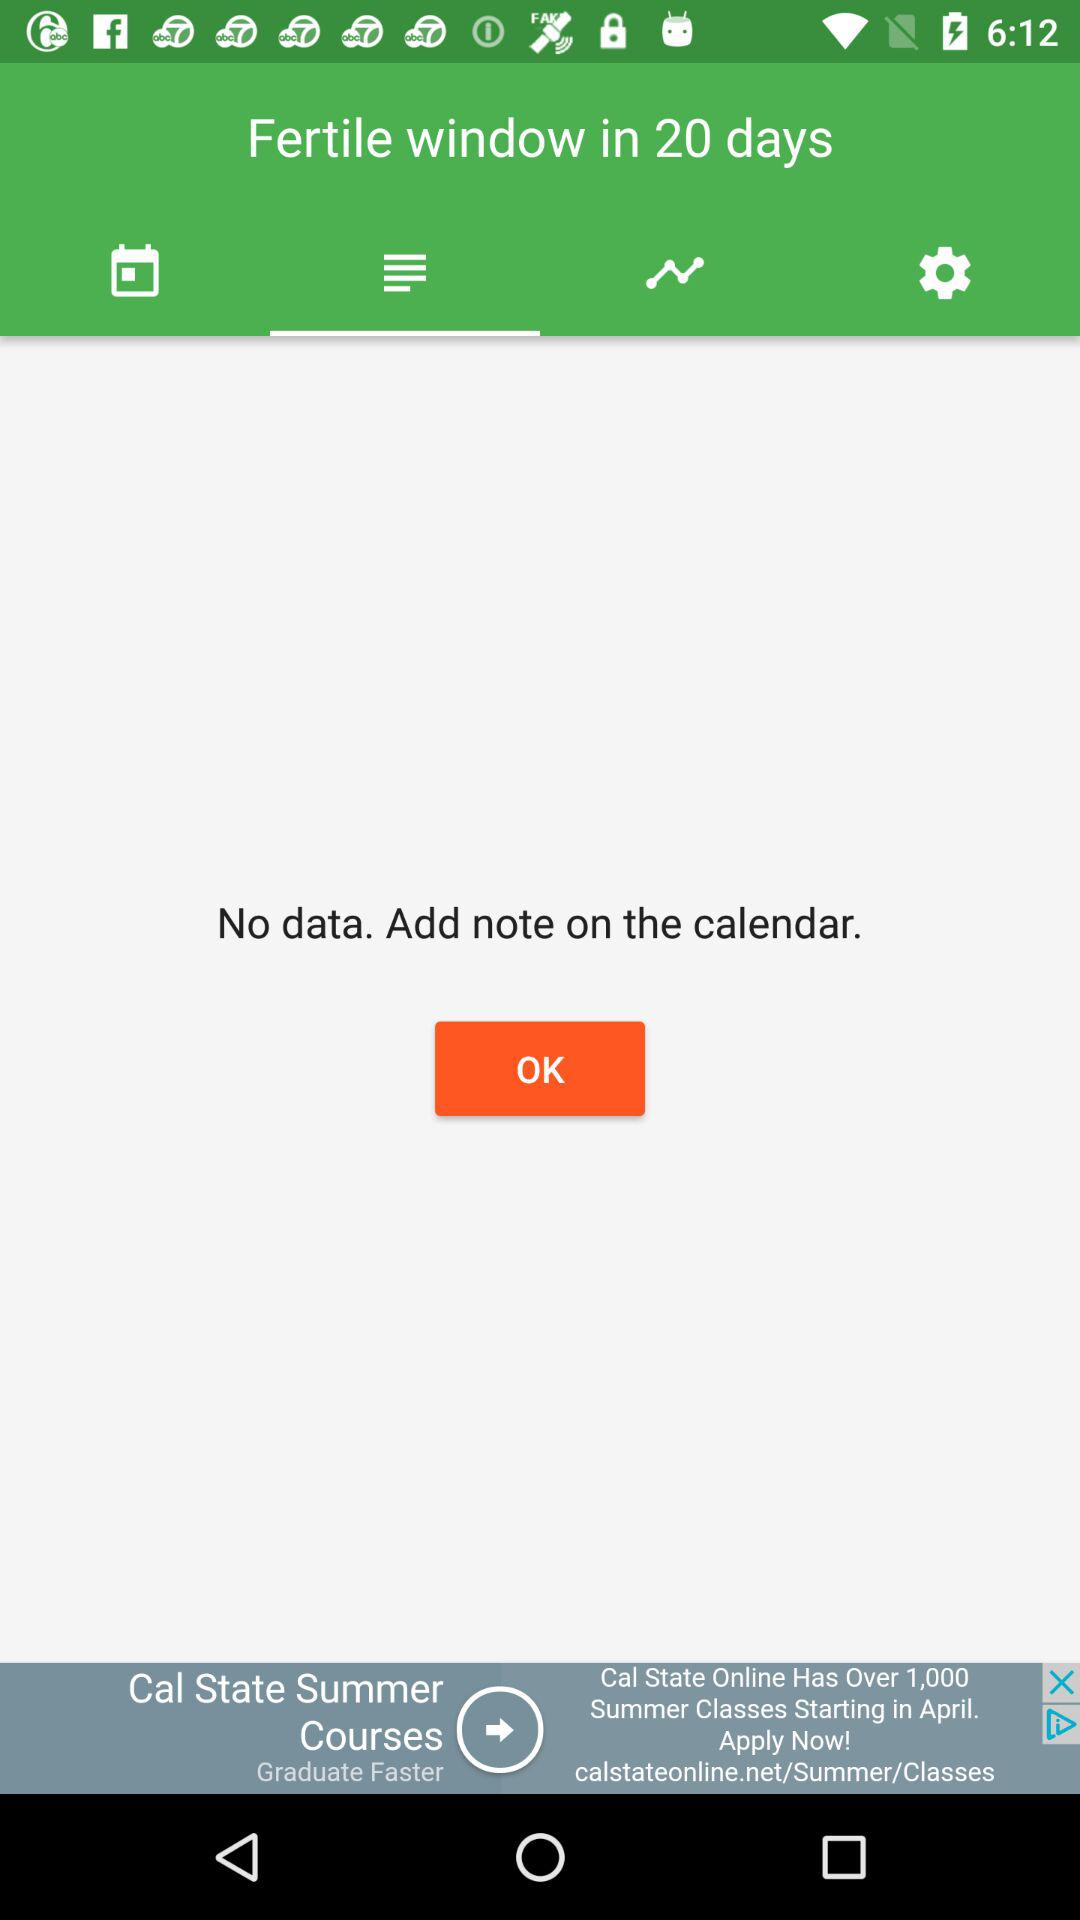Is there any data? There is no data. 